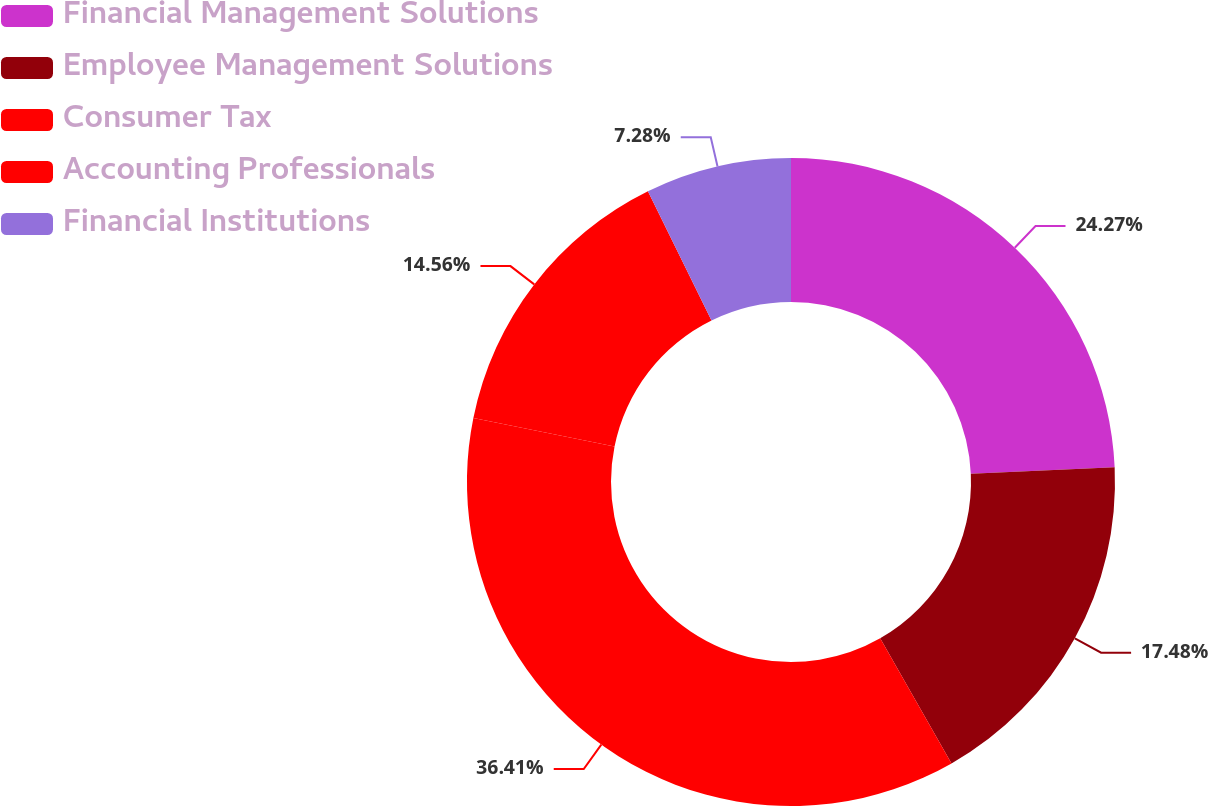<chart> <loc_0><loc_0><loc_500><loc_500><pie_chart><fcel>Financial Management Solutions<fcel>Employee Management Solutions<fcel>Consumer Tax<fcel>Accounting Professionals<fcel>Financial Institutions<nl><fcel>24.27%<fcel>17.48%<fcel>36.41%<fcel>14.56%<fcel>7.28%<nl></chart> 